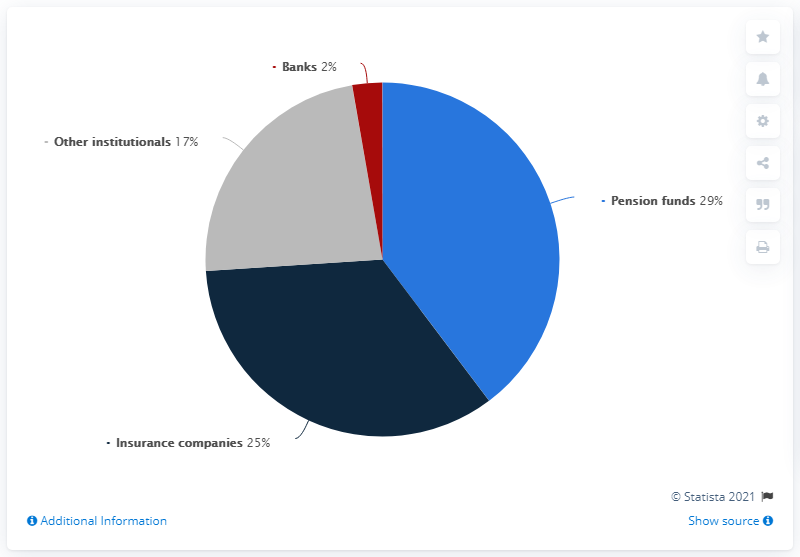Point out several critical features in this image. According to the data provided, approximately 3 out of 10 companies have a market capitalization value below 29 percent. Insurance companies in the pie segment are dark blue in color. 